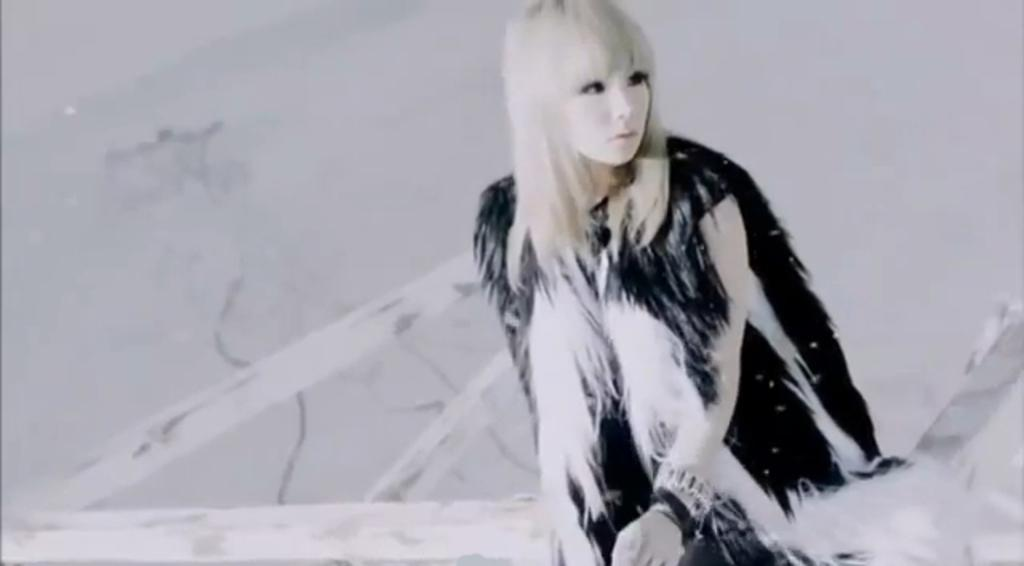What is the main subject of the image? There is a person sitting in the image. What else can be seen in the image besides the person? There are objects in the image. What can be seen behind the person in the image? The background of the image is visible. What type of linen is being used to give the person a haircut in the image? There is no haircut or linen present in the image. How much coal is visible in the image? There is no coal present in the image. 